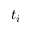Convert formula to latex. <formula><loc_0><loc_0><loc_500><loc_500>t _ { i }</formula> 